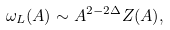<formula> <loc_0><loc_0><loc_500><loc_500>\omega _ { L } ( A ) \sim A ^ { 2 - 2 \Delta } Z ( A ) ,</formula> 